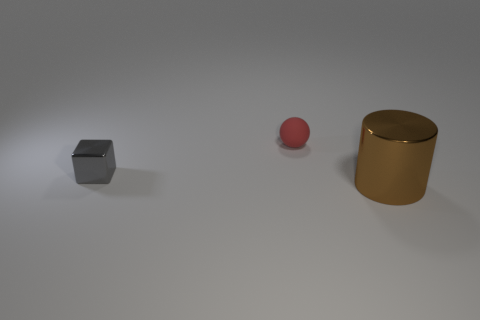Is the number of matte spheres that are in front of the large brown metal object less than the number of tiny brown metallic objects?
Offer a very short reply. No. Are any red matte objects visible?
Provide a succinct answer. Yes. Is the size of the brown cylinder the same as the metallic block?
Offer a terse response. No. There is a thing that is the same material as the brown cylinder; what is its shape?
Give a very brief answer. Cube. What number of other objects are the same shape as the matte object?
Keep it short and to the point. 0. What is the shape of the metal thing that is to the left of the metallic object on the right side of the shiny object that is left of the brown metal cylinder?
Provide a succinct answer. Cube. What number of balls are either red matte things or brown things?
Provide a short and direct response. 1. Are there any tiny cubes behind the object behind the tiny gray thing?
Ensure brevity in your answer.  No. Are there any other things that are made of the same material as the small block?
Offer a terse response. Yes. Does the brown metallic thing have the same shape as the metallic object that is left of the big brown cylinder?
Provide a succinct answer. No. 